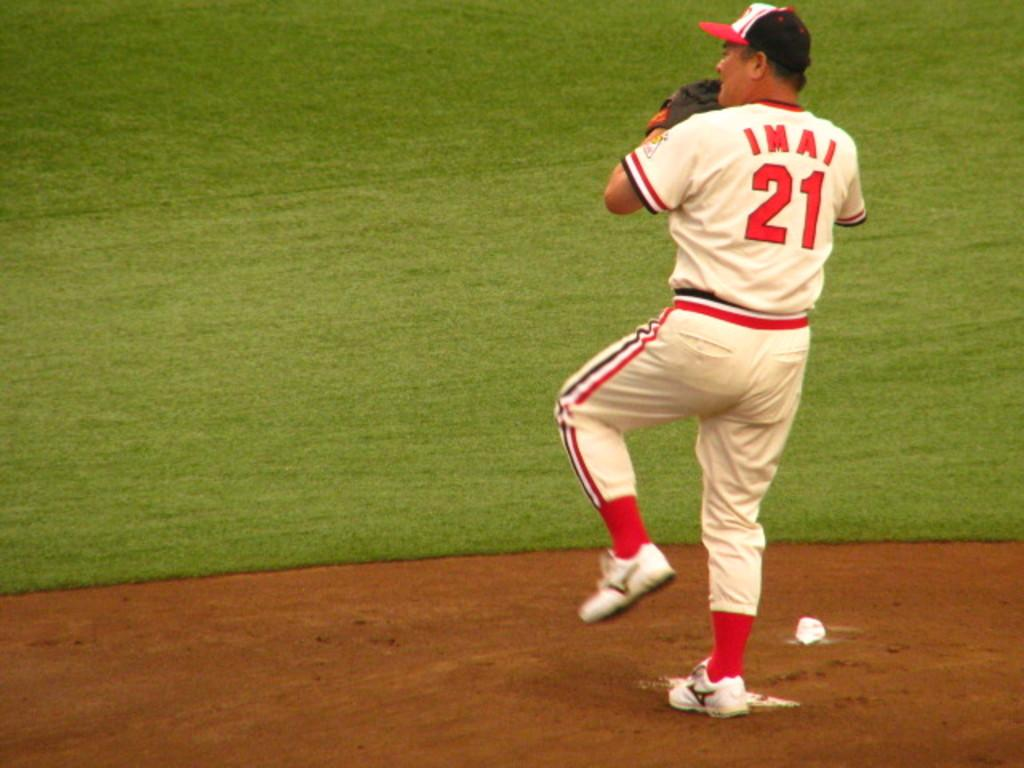<image>
Provide a brief description of the given image. The last name of the pitcher in the game is Imai. 